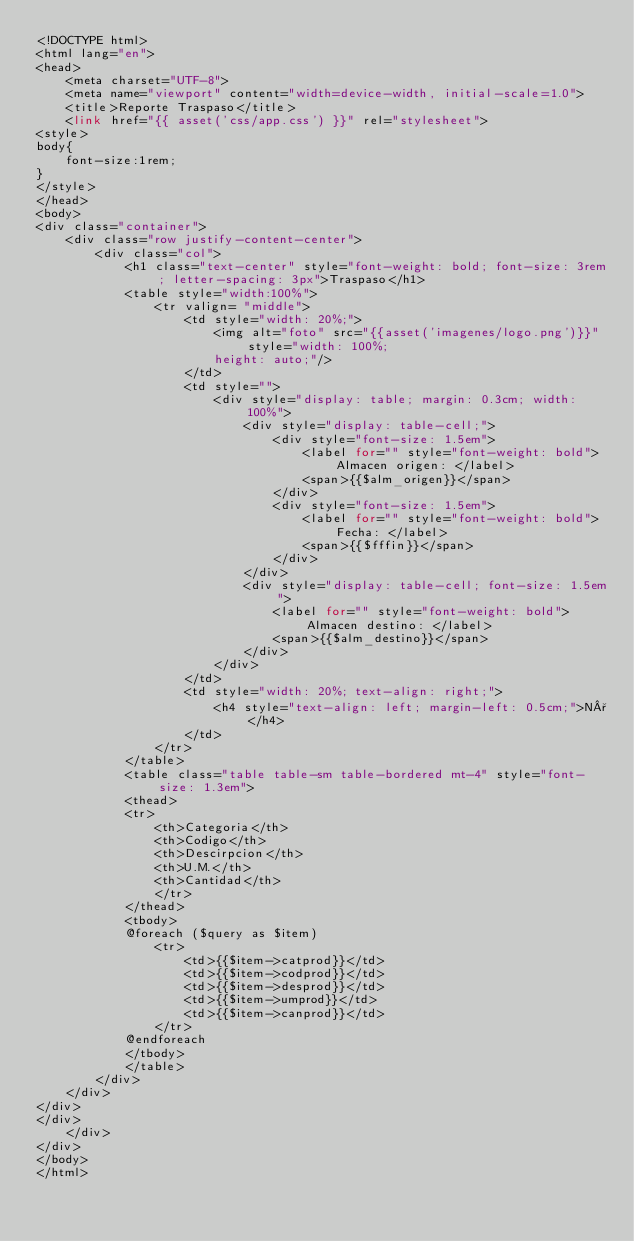Convert code to text. <code><loc_0><loc_0><loc_500><loc_500><_PHP_><!DOCTYPE html>
<html lang="en">
<head>
    <meta charset="UTF-8">
    <meta name="viewport" content="width=device-width, initial-scale=1.0">
    <title>Reporte Traspaso</title>
    <link href="{{ asset('css/app.css') }}" rel="stylesheet">
<style>
body{
    font-size:1rem;
}
</style>
</head>
<body>
<div class="container">
    <div class="row justify-content-center">
        <div class="col">
            <h1 class="text-center" style="font-weight: bold; font-size: 3rem; letter-spacing: 3px">Traspaso</h1>
            <table style="width:100%">
                <tr valign= "middle"> 
                    <td style="width: 20%;">
                        <img alt="foto" src="{{asset('imagenes/logo.png')}}" style="width: 100%;
                        height: auto;"/>      
                    </td>
                    <td style="">
                        <div style="display: table; margin: 0.3cm; width: 100%">
                            <div style="display: table-cell;">
                                <div style="font-size: 1.5em">
                                    <label for="" style="font-weight: bold">Almacen origen: </label>
                                    <span>{{$alm_origen}}</span>
                                </div>
                                <div style="font-size: 1.5em">
                                    <label for="" style="font-weight: bold">Fecha: </label>
                                    <span>{{$fffin}}</span>
                                </div>
                            </div>
                            <div style="display: table-cell; font-size: 1.5em">
                                <label for="" style="font-weight: bold">Almacen destino: </label>
                                <span>{{$alm_destino}}</span>
                            </div>
                        </div>
                    </td>
                    <td style="width: 20%; text-align: right;">
                        <h4 style="text-align: left; margin-left: 0.5cm;">N°</h4>
                    </td>
                </tr>                       
            </table>
            <table class="table table-sm table-bordered mt-4" style="font-size: 1.3em">
            <thead>
            <tr>
                <th>Categoria</th>
                <th>Codigo</th>
                <th>Descirpcion</th>
                <th>U.M.</th>
                <th>Cantidad</th>
                </tr>
            </thead>
            <tbody>
            @foreach ($query as $item)
                <tr>
                    <td>{{$item->catprod}}</td>
                    <td>{{$item->codprod}}</td>
                    <td>{{$item->desprod}}</td>
                    <td>{{$item->umprod}}</td>
                    <td>{{$item->canprod}}</td>
                </tr>
            @endforeach         
            </tbody>
            </table>        
        </div>
    </div>
</div>
</div>
    </div>
</div>
</body>
</html></code> 